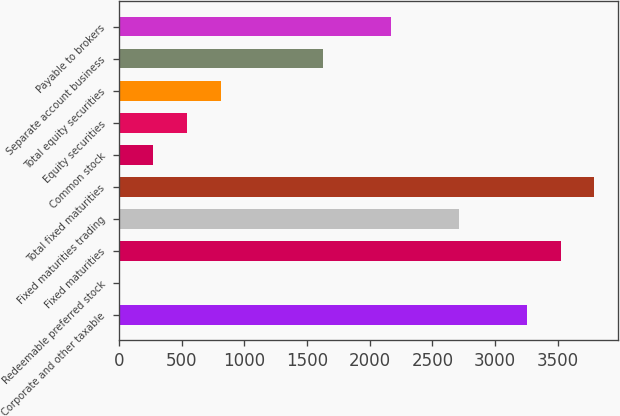Convert chart to OTSL. <chart><loc_0><loc_0><loc_500><loc_500><bar_chart><fcel>Corporate and other taxable<fcel>Redeemable preferred stock<fcel>Fixed maturities<fcel>Fixed maturities trading<fcel>Total fixed maturities<fcel>Common stock<fcel>Equity securities<fcel>Total equity securities<fcel>Separate account business<fcel>Payable to brokers<nl><fcel>3251.6<fcel>2<fcel>3522.4<fcel>2710<fcel>3793.2<fcel>272.8<fcel>543.6<fcel>814.4<fcel>1626.8<fcel>2168.4<nl></chart> 